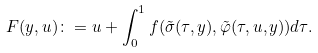Convert formula to latex. <formula><loc_0><loc_0><loc_500><loc_500>F ( y , u ) \colon = u + \int _ { 0 } ^ { 1 } f ( \tilde { \sigma } ( \tau , y ) , \tilde { \varphi } ( \tau , u , y ) ) d \tau .</formula> 